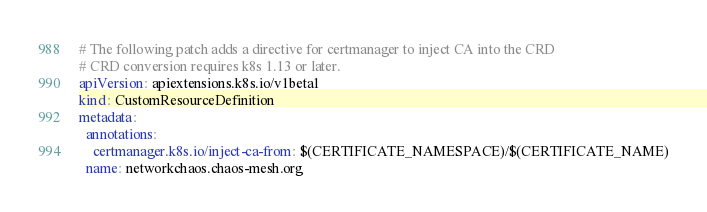Convert code to text. <code><loc_0><loc_0><loc_500><loc_500><_YAML_># The following patch adds a directive for certmanager to inject CA into the CRD
# CRD conversion requires k8s 1.13 or later.
apiVersion: apiextensions.k8s.io/v1beta1
kind: CustomResourceDefinition
metadata:
  annotations:
    certmanager.k8s.io/inject-ca-from: $(CERTIFICATE_NAMESPACE)/$(CERTIFICATE_NAME)
  name: networkchaos.chaos-mesh.org
</code> 